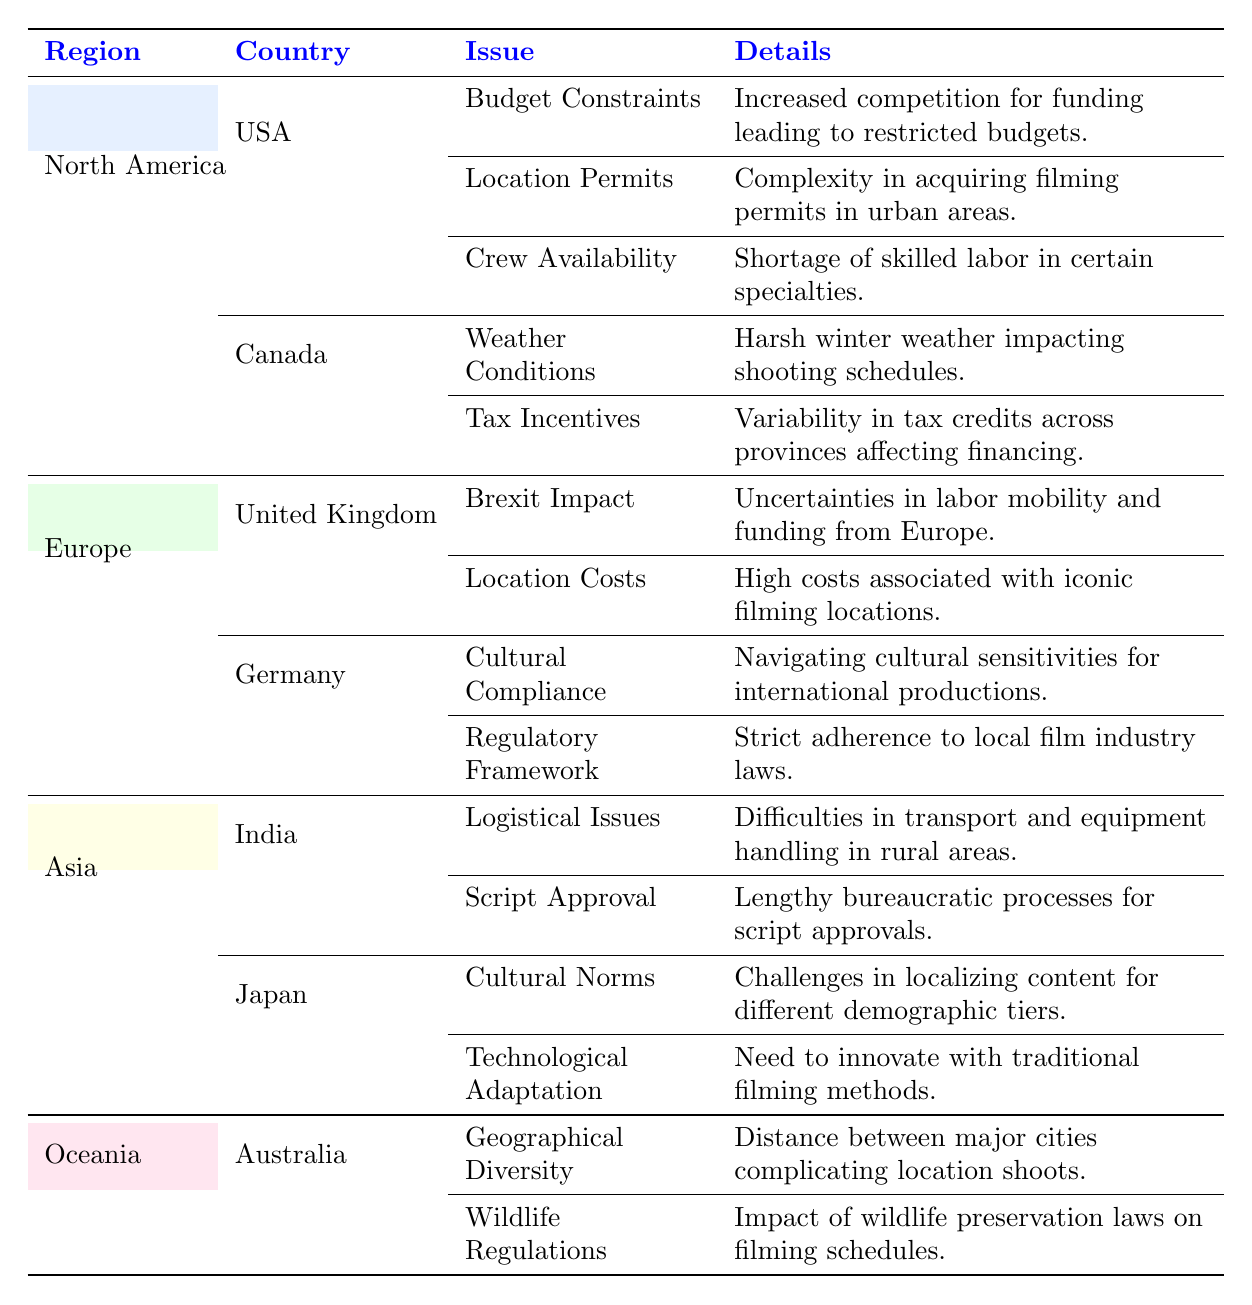What production challenge faces filmmakers in the USA? From the table, we can see that there are three listed challenges for the USA: Budget Constraints, Location Permits, and Crew Availability.
Answer: Budget Constraints, Location Permits, Crew Availability Which country in Europe has issues related to Brexit? The table indicates that the United Kingdom is the country in Europe facing challenges related to Brexit Impact.
Answer: United Kingdom What are the challenges faced by filmmakers in Canada? The table lists two challenges for Canada: Weather Conditions and Tax Incentives.
Answer: Weather Conditions, Tax Incentives True or False: Japan faces challenges with cultural norms in filmmaking. The table explicitly states that Japan has challenges related to Cultural Norms, indicating that this statement is true.
Answer: True What are the details regarding the issue of script approval in India? According to the table, the challenge of Script Approval in India involves lengthy bureaucratic processes for script approvals.
Answer: Lengthy bureaucratic processes for script approvals How many challenges are listed for filmmakers in Australia? The table shows that there are two challenges listed for Australia: Geographical Diversity and Wildlife Regulations. Therefore, the total is 2.
Answer: 2 Which region faces challenges due to geographical diversity? The table indicates that Australia, in the Oceania region, faces challenges due to Geographical Diversity.
Answer: Oceania What are the total number of challenges identified in North America? In North America, the USA has three challenges and Canada has two challenges. Adding these gives a total of 3 + 2 = 5 challenges.
Answer: 5 What impact of Brexit is identified in the UK? The table notes that the impact of Brexit in the UK includes uncertainties in labor mobility and funding from Europe.
Answer: Uncertainties in labor mobility and funding from Europe 